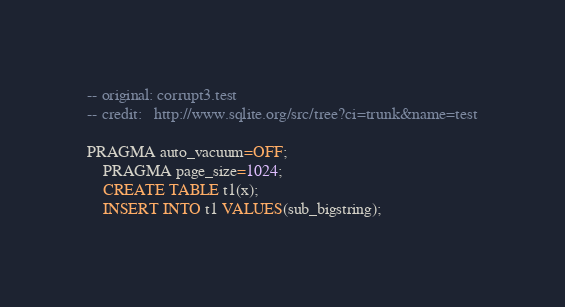<code> <loc_0><loc_0><loc_500><loc_500><_SQL_>-- original: corrupt3.test
-- credit:   http://www.sqlite.org/src/tree?ci=trunk&name=test

PRAGMA auto_vacuum=OFF;
    PRAGMA page_size=1024;
    CREATE TABLE t1(x);
    INSERT INTO t1 VALUES(sub_bigstring);</code> 